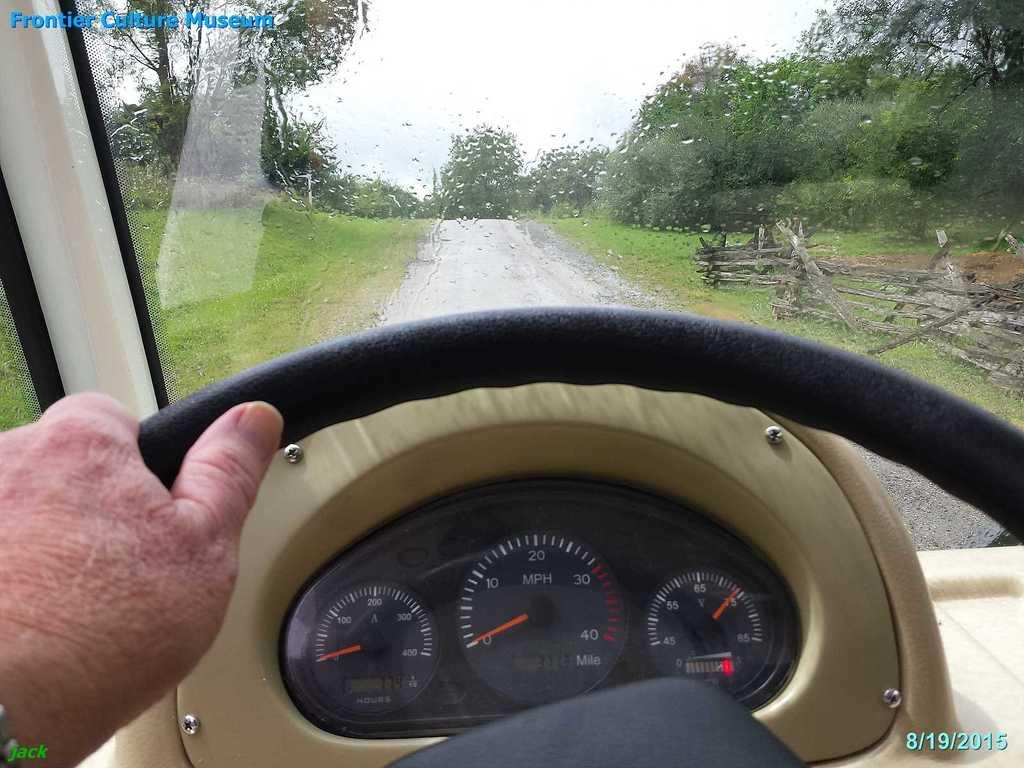What is located in the center of the image? There is a steering wheel, an indicator, a person's leg, and a person's hand in the center of the image. What can be seen in the background of the image? There is a mirror, trees, a road, and the sky visible in the background of the image. Are there any fairies visible in the image? No, there are no fairies present in the image. What impulse might the person in the image be experiencing? The image does not provide any information about the person's emotions or impulses, so it cannot be determined from the image. 